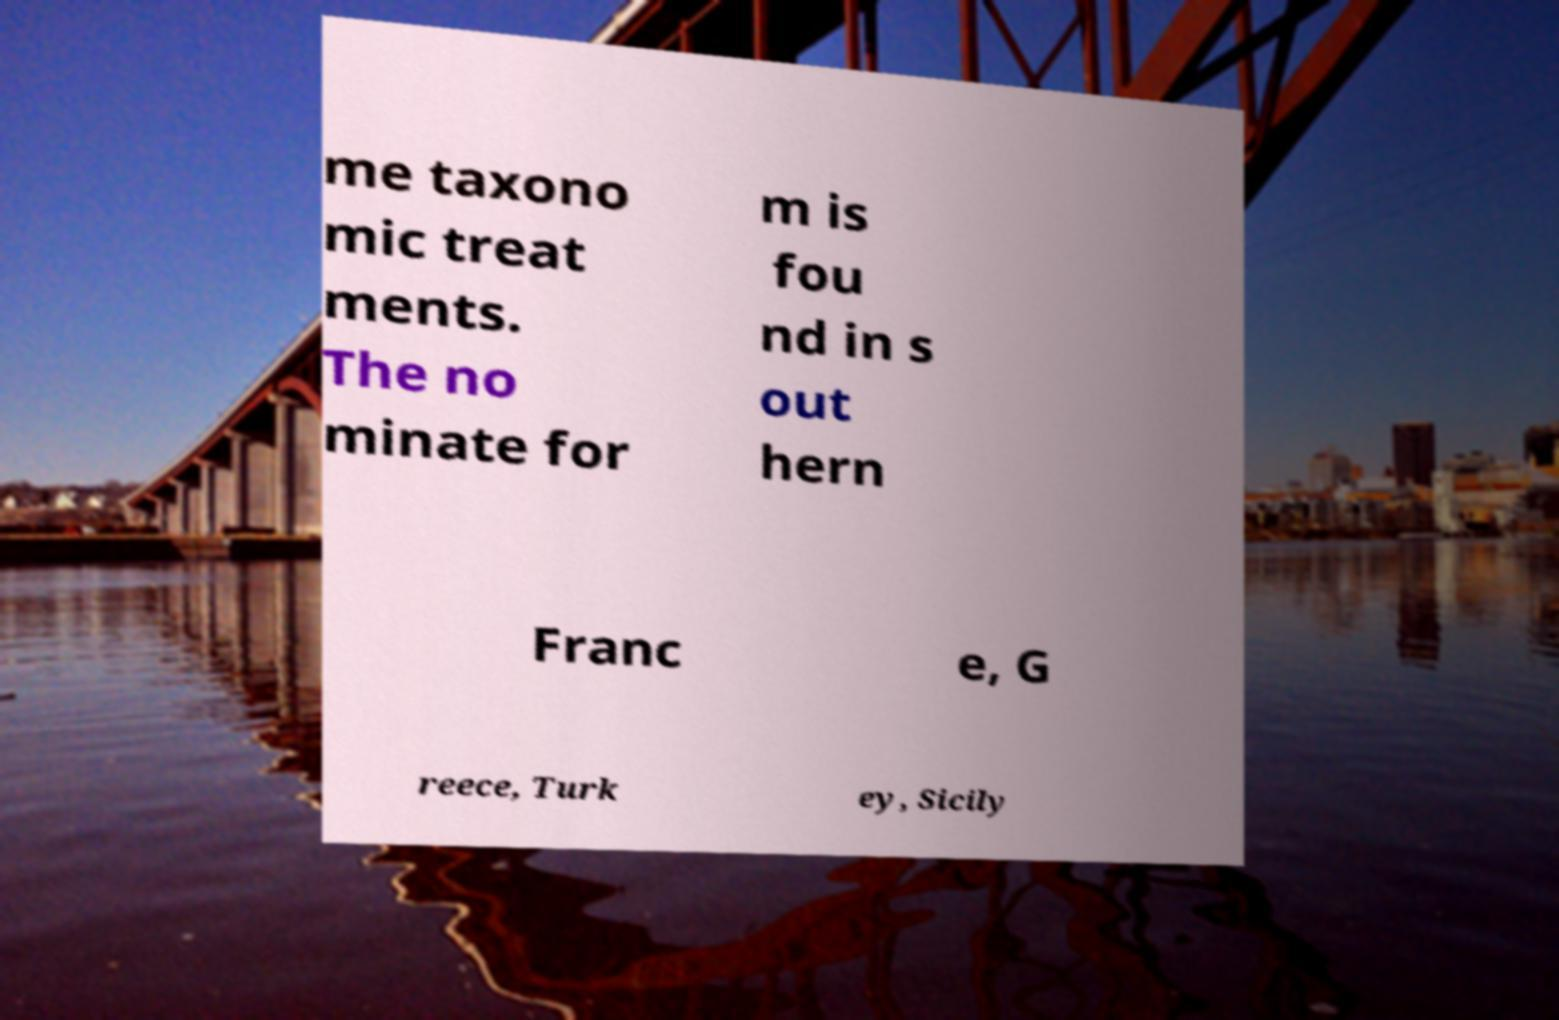Could you assist in decoding the text presented in this image and type it out clearly? me taxono mic treat ments. The no minate for m is fou nd in s out hern Franc e, G reece, Turk ey, Sicily 